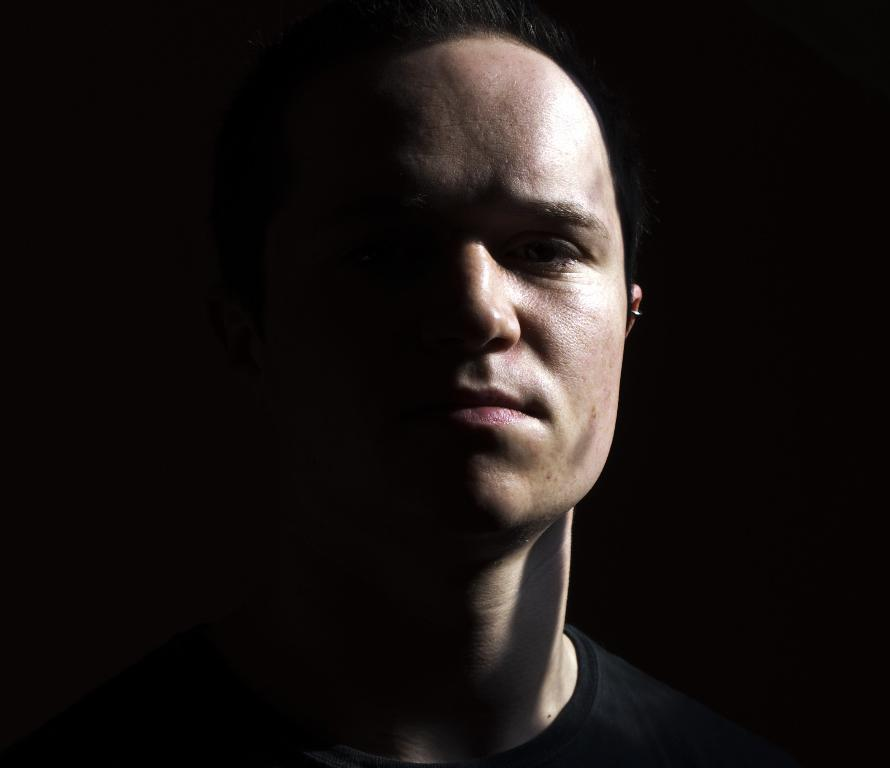What is the main subject of the image? There is a person in the image. What type of school does the person attend in the image? There is no information about a school or any educational institution in the image. What type of bird, such as a wren, can be seen flying in the image? There is no bird present in the image. 